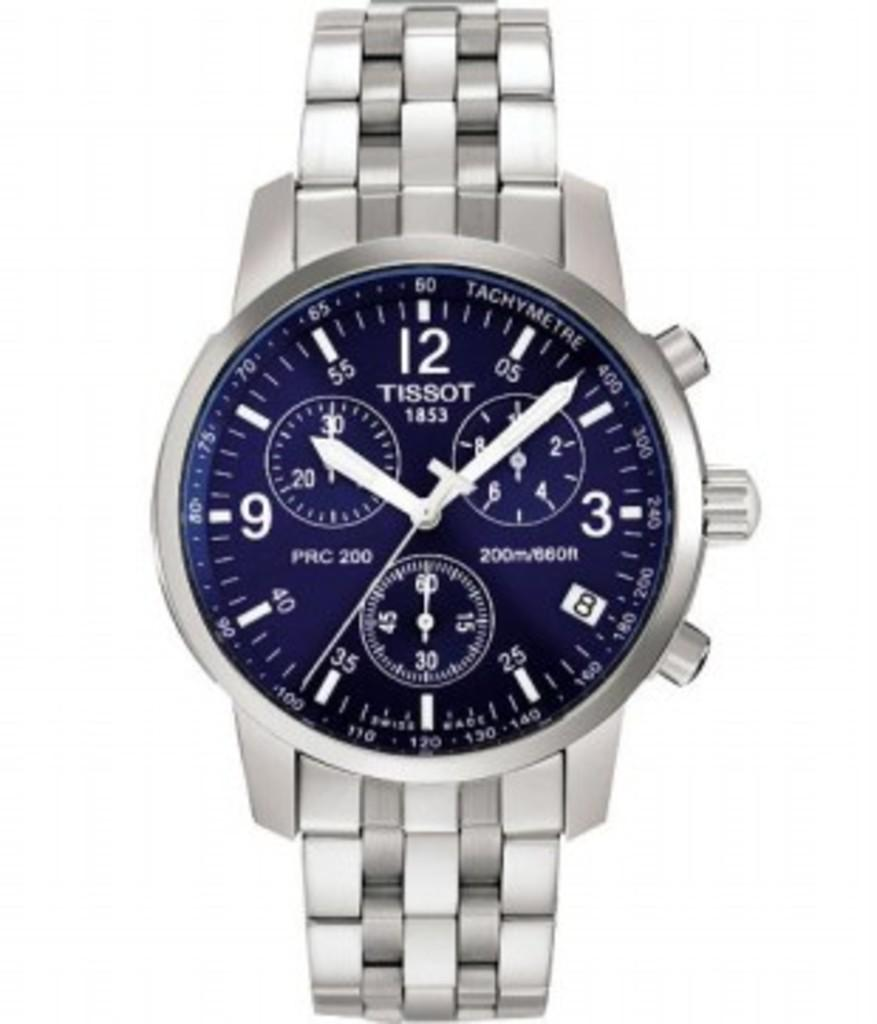<image>
Give a short and clear explanation of the subsequent image. A silver Tissot watch has a blue face. 